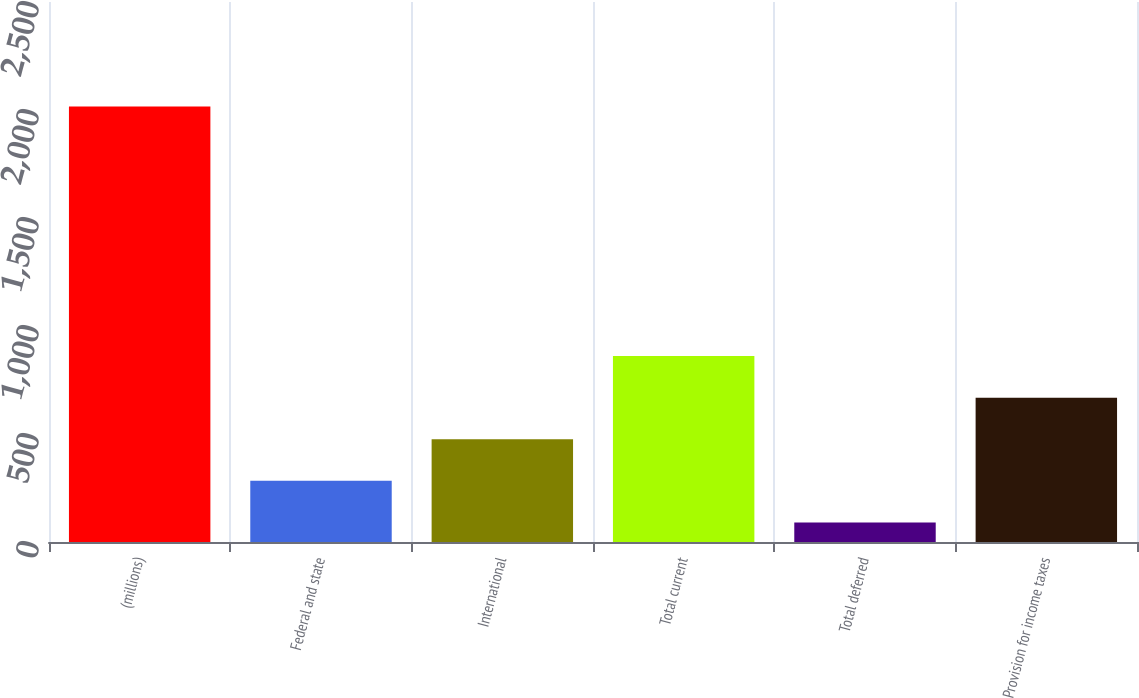<chart> <loc_0><loc_0><loc_500><loc_500><bar_chart><fcel>(millions)<fcel>Federal and state<fcel>International<fcel>Total current<fcel>Total deferred<fcel>Provision for income taxes<nl><fcel>2016<fcel>283.14<fcel>475.68<fcel>860.76<fcel>90.6<fcel>668.22<nl></chart> 